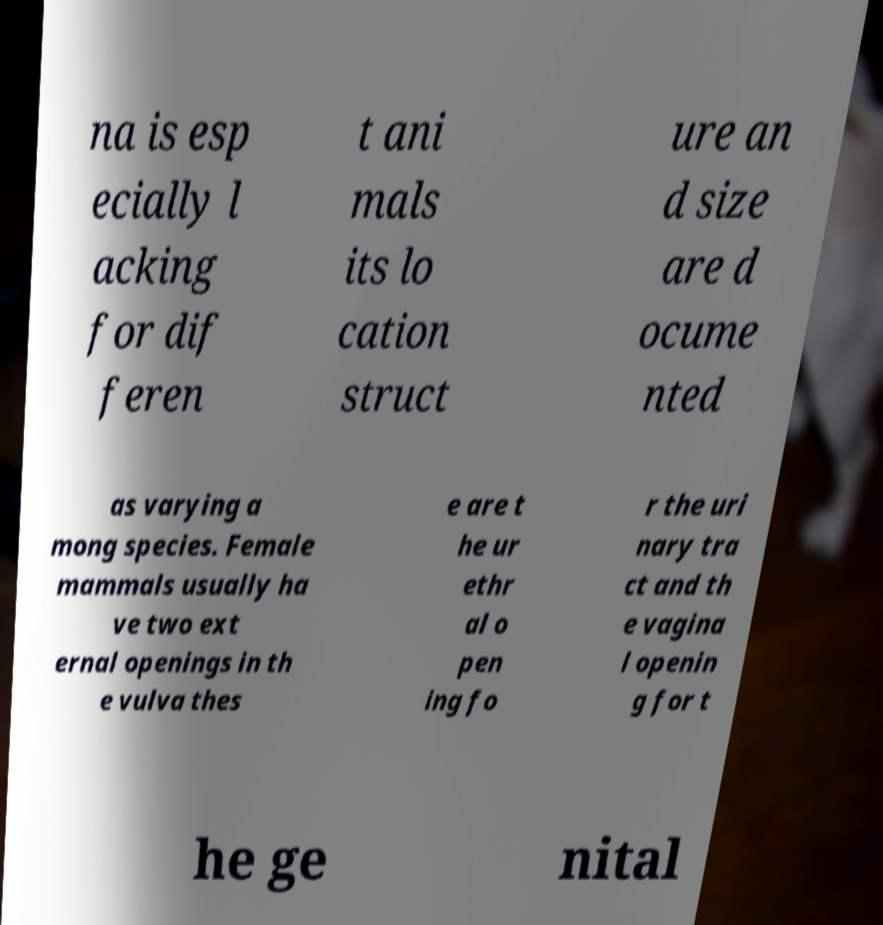Please identify and transcribe the text found in this image. na is esp ecially l acking for dif feren t ani mals its lo cation struct ure an d size are d ocume nted as varying a mong species. Female mammals usually ha ve two ext ernal openings in th e vulva thes e are t he ur ethr al o pen ing fo r the uri nary tra ct and th e vagina l openin g for t he ge nital 